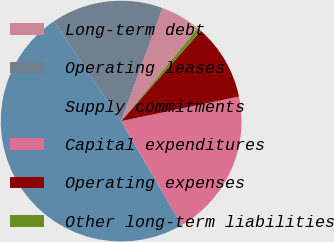Convert chart to OTSL. <chart><loc_0><loc_0><loc_500><loc_500><pie_chart><fcel>Long-term debt<fcel>Operating leases<fcel>Supply commitments<fcel>Capital expenditures<fcel>Operating expenses<fcel>Other long-term liabilities<nl><fcel>5.38%<fcel>15.05%<fcel>48.92%<fcel>19.89%<fcel>10.22%<fcel>0.54%<nl></chart> 